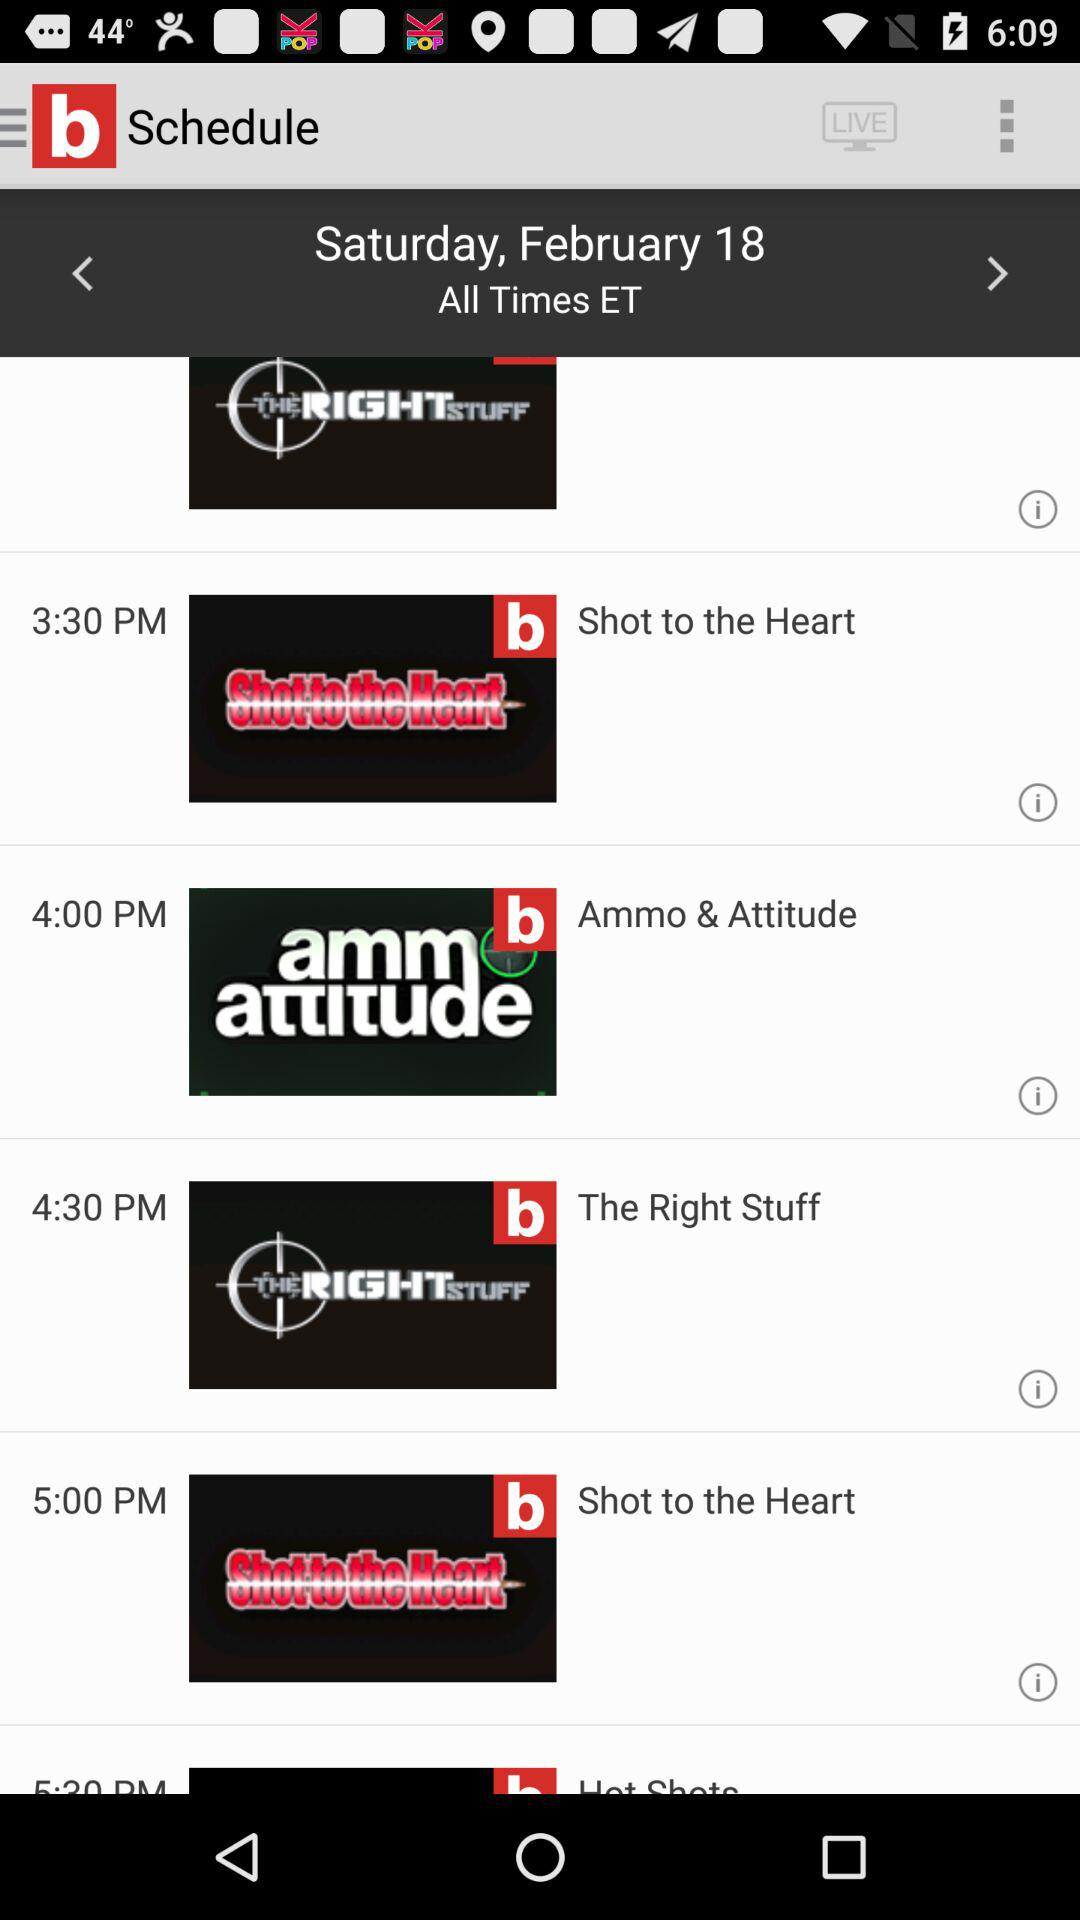What is the date? The date is Saturday, February 18. 